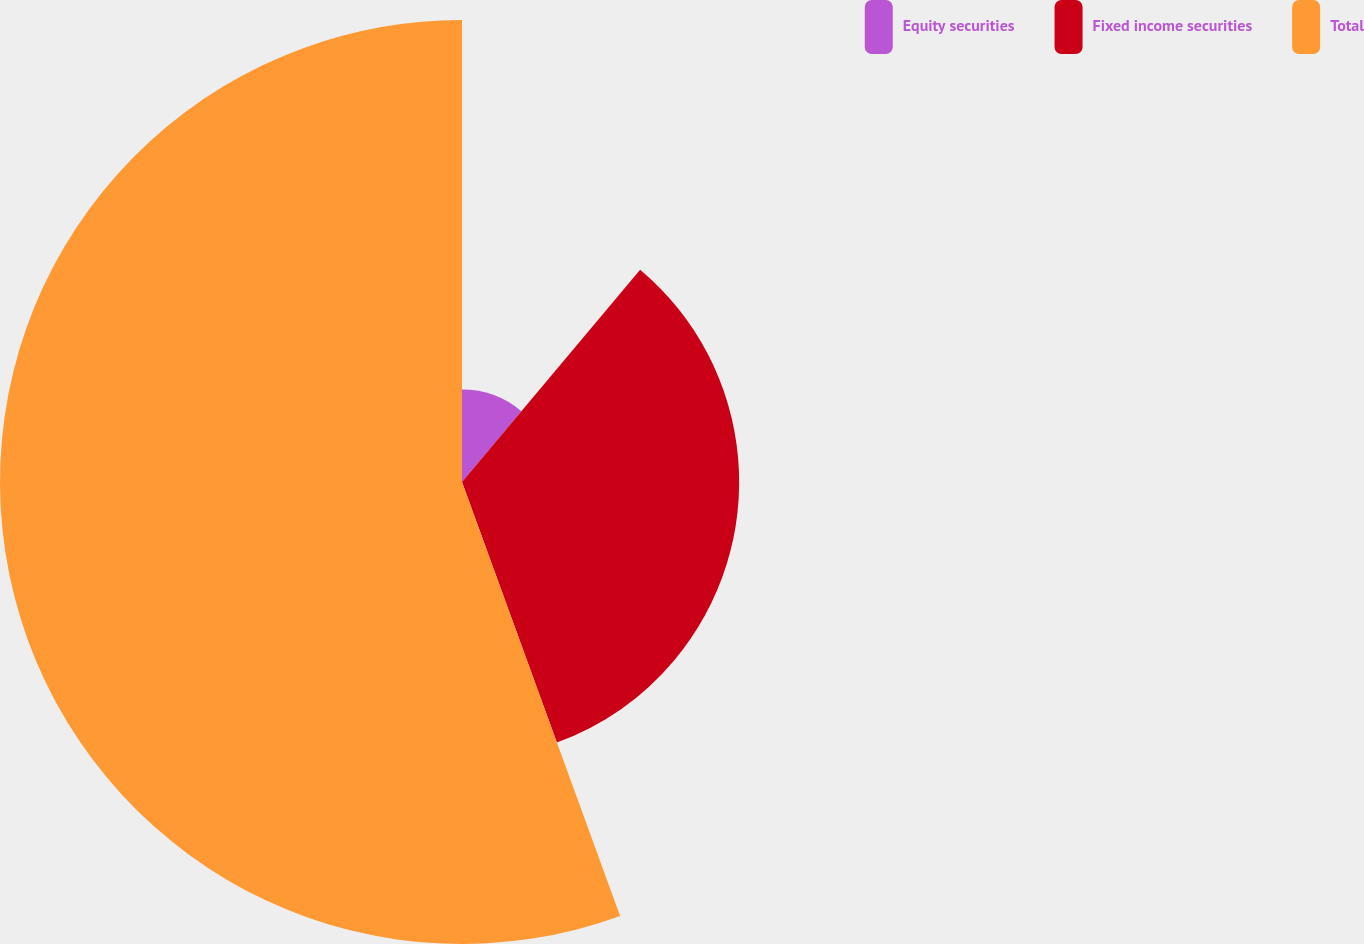Convert chart. <chart><loc_0><loc_0><loc_500><loc_500><pie_chart><fcel>Equity securities<fcel>Fixed income securities<fcel>Total<nl><fcel>11.11%<fcel>33.33%<fcel>55.56%<nl></chart> 